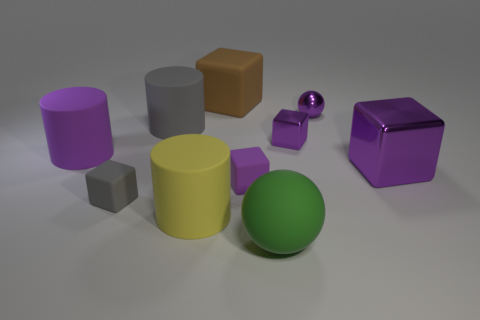There is a sphere that is the same material as the large purple cube; what color is it?
Provide a short and direct response. Purple. How many tiny cubes are the same material as the green sphere?
Provide a succinct answer. 2. Do the gray object that is in front of the large purple metal thing and the sphere that is behind the tiny purple matte block have the same size?
Your answer should be compact. Yes. The large cylinder that is behind the small purple metallic thing in front of the tiny purple sphere is made of what material?
Ensure brevity in your answer.  Rubber. Is the number of yellow rubber things behind the purple cylinder less than the number of tiny purple metallic objects on the right side of the large rubber ball?
Provide a short and direct response. Yes. What is the material of the large cylinder that is the same color as the large shiny cube?
Your response must be concise. Rubber. Are there any other things that are the same shape as the tiny purple matte thing?
Make the answer very short. Yes. What is the large block that is in front of the big purple rubber cylinder made of?
Offer a very short reply. Metal. Are there any tiny purple metal spheres in front of the green ball?
Keep it short and to the point. No. The yellow matte object is what shape?
Provide a succinct answer. Cylinder. 